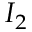<formula> <loc_0><loc_0><loc_500><loc_500>I _ { 2 }</formula> 